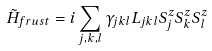Convert formula to latex. <formula><loc_0><loc_0><loc_500><loc_500>\tilde { H } _ { f r u s t } = i \sum _ { j , k , l } \gamma _ { j k l } L _ { j k l } S ^ { z } _ { j } S ^ { z } _ { k } S ^ { z } _ { l }</formula> 